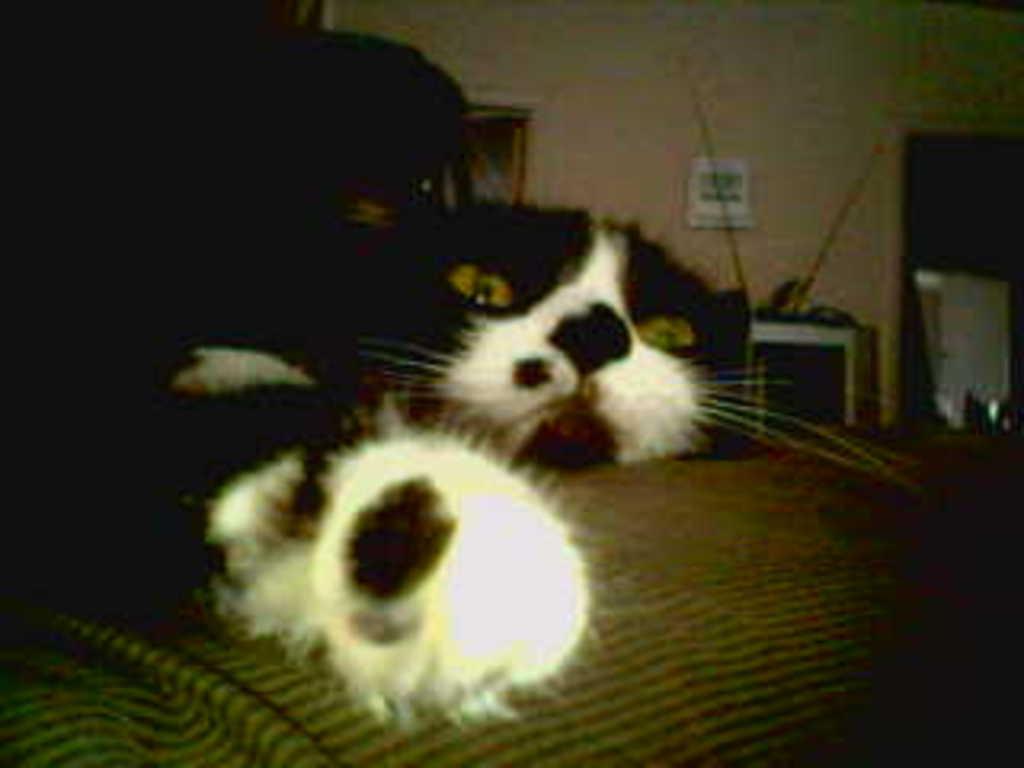Please provide a concise description of this image. This image is taken indoors. In the background there is a wall with a door and there is a picture frame on the wall. There is a table with a few things on it. At the bottom of the image there is a bed. In the middle of the image there are two cats lying on the bed. 